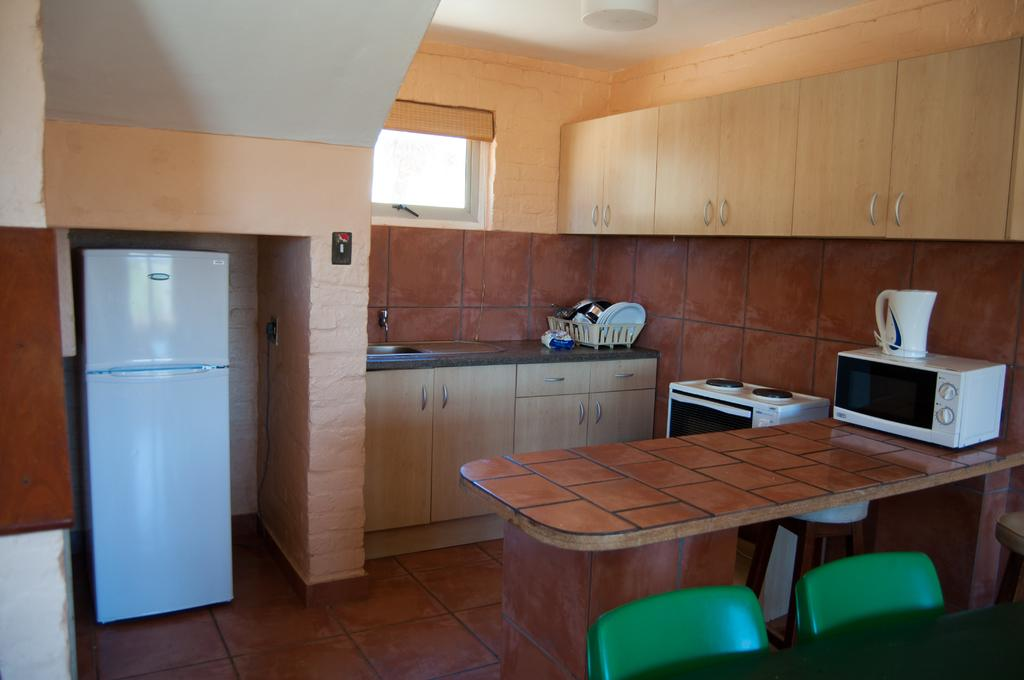What type of space is shown in the image? The image depicts the interior of a room. What appliances can be seen in the room? There is a refrigerator, an oven, and a gas stove in the room. What furniture is present in the room? There are chairs and a table in the room. What other items can be found in the room? There is cutlery, a tap, and cupboards in the room. What type of territory is being claimed by the oven in the image? There is no territory being claimed by the oven in the image; it is simply an appliance in the room. 